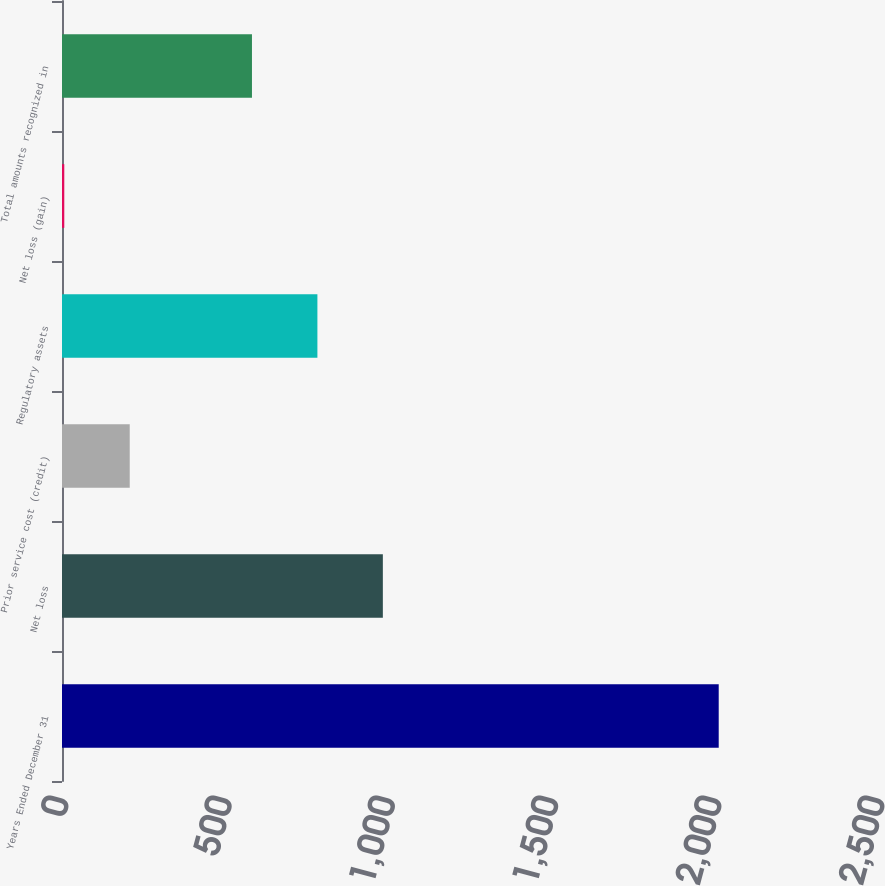Convert chart to OTSL. <chart><loc_0><loc_0><loc_500><loc_500><bar_chart><fcel>Years Ended December 31<fcel>Net loss<fcel>Prior service cost (credit)<fcel>Regulatory assets<fcel>Net loss (gain)<fcel>Total amounts recognized in<nl><fcel>2012<fcel>983<fcel>207.5<fcel>782.5<fcel>7<fcel>582<nl></chart> 